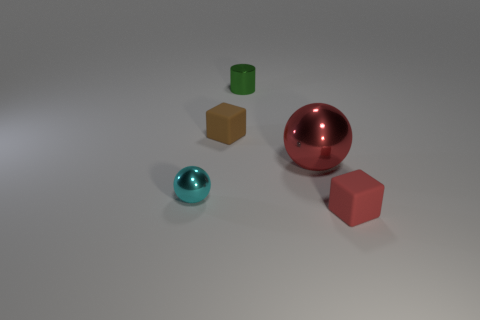Add 1 shiny things. How many objects exist? 6 Subtract all cubes. How many objects are left? 3 Subtract 1 brown blocks. How many objects are left? 4 Subtract all small metallic cubes. Subtract all metallic cylinders. How many objects are left? 4 Add 4 blocks. How many blocks are left? 6 Add 4 cyan shiny balls. How many cyan shiny balls exist? 5 